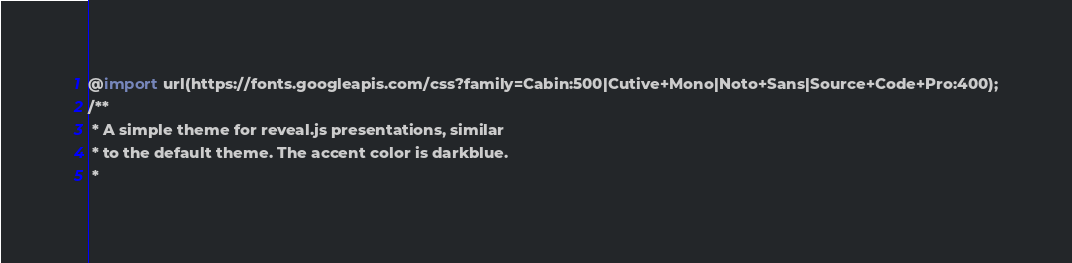Convert code to text. <code><loc_0><loc_0><loc_500><loc_500><_CSS_>@import url(https://fonts.googleapis.com/css?family=Cabin:500|Cutive+Mono|Noto+Sans|Source+Code+Pro:400);
/**
 * A simple theme for reveal.js presentations, similar
 * to the default theme. The accent color is darkblue.
 *</code> 